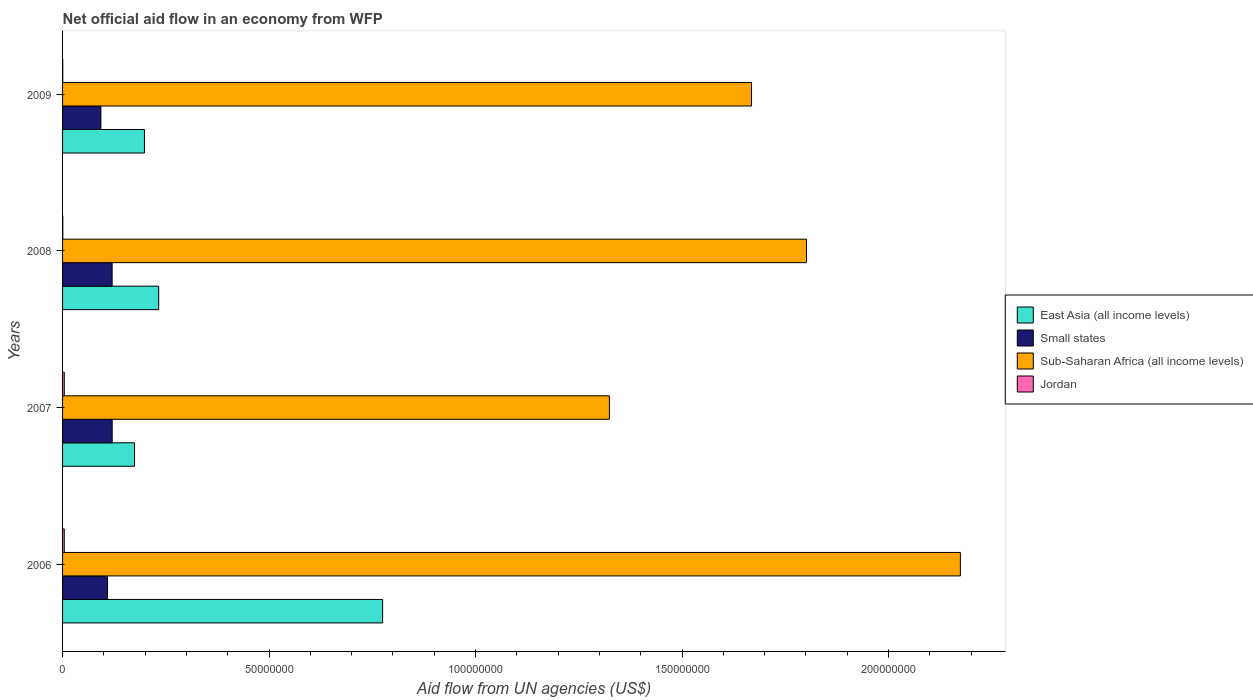How many different coloured bars are there?
Offer a very short reply. 4. How many groups of bars are there?
Offer a very short reply. 4. Are the number of bars per tick equal to the number of legend labels?
Offer a terse response. Yes. Are the number of bars on each tick of the Y-axis equal?
Give a very brief answer. Yes. How many bars are there on the 1st tick from the bottom?
Your response must be concise. 4. What is the net official aid flow in Jordan in 2009?
Offer a terse response. 5.00e+04. Across all years, what is the maximum net official aid flow in Sub-Saharan Africa (all income levels)?
Give a very brief answer. 2.17e+08. Across all years, what is the minimum net official aid flow in Sub-Saharan Africa (all income levels)?
Ensure brevity in your answer.  1.32e+08. What is the total net official aid flow in Sub-Saharan Africa (all income levels) in the graph?
Your response must be concise. 6.97e+08. What is the difference between the net official aid flow in Small states in 2006 and that in 2009?
Provide a short and direct response. 1.61e+06. What is the difference between the net official aid flow in Jordan in 2009 and the net official aid flow in East Asia (all income levels) in 2007?
Make the answer very short. -1.74e+07. What is the average net official aid flow in Jordan per year?
Keep it short and to the point. 2.35e+05. In the year 2008, what is the difference between the net official aid flow in Jordan and net official aid flow in Small states?
Your answer should be compact. -1.19e+07. What is the ratio of the net official aid flow in Small states in 2006 to that in 2008?
Give a very brief answer. 0.91. Is the net official aid flow in Sub-Saharan Africa (all income levels) in 2006 less than that in 2007?
Your answer should be compact. No. Is the difference between the net official aid flow in Jordan in 2008 and 2009 greater than the difference between the net official aid flow in Small states in 2008 and 2009?
Provide a succinct answer. No. What is the difference between the highest and the lowest net official aid flow in East Asia (all income levels)?
Your response must be concise. 6.01e+07. Is the sum of the net official aid flow in Small states in 2007 and 2009 greater than the maximum net official aid flow in East Asia (all income levels) across all years?
Your response must be concise. No. Is it the case that in every year, the sum of the net official aid flow in Sub-Saharan Africa (all income levels) and net official aid flow in Jordan is greater than the sum of net official aid flow in East Asia (all income levels) and net official aid flow in Small states?
Ensure brevity in your answer.  Yes. What does the 1st bar from the top in 2009 represents?
Provide a short and direct response. Jordan. What does the 4th bar from the bottom in 2008 represents?
Your response must be concise. Jordan. How many bars are there?
Your answer should be very brief. 16. Are all the bars in the graph horizontal?
Provide a succinct answer. Yes. What is the difference between two consecutive major ticks on the X-axis?
Ensure brevity in your answer.  5.00e+07. Does the graph contain grids?
Offer a very short reply. No. How many legend labels are there?
Offer a terse response. 4. How are the legend labels stacked?
Keep it short and to the point. Vertical. What is the title of the graph?
Your response must be concise. Net official aid flow in an economy from WFP. Does "Mali" appear as one of the legend labels in the graph?
Your answer should be very brief. No. What is the label or title of the X-axis?
Give a very brief answer. Aid flow from UN agencies (US$). What is the Aid flow from UN agencies (US$) of East Asia (all income levels) in 2006?
Keep it short and to the point. 7.75e+07. What is the Aid flow from UN agencies (US$) in Small states in 2006?
Offer a very short reply. 1.09e+07. What is the Aid flow from UN agencies (US$) in Sub-Saharan Africa (all income levels) in 2006?
Your response must be concise. 2.17e+08. What is the Aid flow from UN agencies (US$) of Jordan in 2006?
Your answer should be compact. 4.10e+05. What is the Aid flow from UN agencies (US$) of East Asia (all income levels) in 2007?
Give a very brief answer. 1.74e+07. What is the Aid flow from UN agencies (US$) of Small states in 2007?
Your answer should be compact. 1.20e+07. What is the Aid flow from UN agencies (US$) of Sub-Saharan Africa (all income levels) in 2007?
Provide a short and direct response. 1.32e+08. What is the Aid flow from UN agencies (US$) in Jordan in 2007?
Give a very brief answer. 4.20e+05. What is the Aid flow from UN agencies (US$) of East Asia (all income levels) in 2008?
Your answer should be very brief. 2.33e+07. What is the Aid flow from UN agencies (US$) of Sub-Saharan Africa (all income levels) in 2008?
Provide a succinct answer. 1.80e+08. What is the Aid flow from UN agencies (US$) in Jordan in 2008?
Your answer should be compact. 6.00e+04. What is the Aid flow from UN agencies (US$) in East Asia (all income levels) in 2009?
Provide a succinct answer. 1.98e+07. What is the Aid flow from UN agencies (US$) of Small states in 2009?
Your answer should be compact. 9.28e+06. What is the Aid flow from UN agencies (US$) in Sub-Saharan Africa (all income levels) in 2009?
Provide a succinct answer. 1.67e+08. What is the Aid flow from UN agencies (US$) in Jordan in 2009?
Offer a terse response. 5.00e+04. Across all years, what is the maximum Aid flow from UN agencies (US$) in East Asia (all income levels)?
Make the answer very short. 7.75e+07. Across all years, what is the maximum Aid flow from UN agencies (US$) in Small states?
Ensure brevity in your answer.  1.20e+07. Across all years, what is the maximum Aid flow from UN agencies (US$) in Sub-Saharan Africa (all income levels)?
Ensure brevity in your answer.  2.17e+08. Across all years, what is the minimum Aid flow from UN agencies (US$) in East Asia (all income levels)?
Ensure brevity in your answer.  1.74e+07. Across all years, what is the minimum Aid flow from UN agencies (US$) of Small states?
Your answer should be compact. 9.28e+06. Across all years, what is the minimum Aid flow from UN agencies (US$) of Sub-Saharan Africa (all income levels)?
Keep it short and to the point. 1.32e+08. Across all years, what is the minimum Aid flow from UN agencies (US$) in Jordan?
Your answer should be compact. 5.00e+04. What is the total Aid flow from UN agencies (US$) in East Asia (all income levels) in the graph?
Your answer should be compact. 1.38e+08. What is the total Aid flow from UN agencies (US$) in Small states in the graph?
Your answer should be compact. 4.42e+07. What is the total Aid flow from UN agencies (US$) of Sub-Saharan Africa (all income levels) in the graph?
Your answer should be very brief. 6.97e+08. What is the total Aid flow from UN agencies (US$) of Jordan in the graph?
Provide a short and direct response. 9.40e+05. What is the difference between the Aid flow from UN agencies (US$) of East Asia (all income levels) in 2006 and that in 2007?
Make the answer very short. 6.01e+07. What is the difference between the Aid flow from UN agencies (US$) of Small states in 2006 and that in 2007?
Offer a terse response. -1.12e+06. What is the difference between the Aid flow from UN agencies (US$) of Sub-Saharan Africa (all income levels) in 2006 and that in 2007?
Make the answer very short. 8.50e+07. What is the difference between the Aid flow from UN agencies (US$) of East Asia (all income levels) in 2006 and that in 2008?
Your response must be concise. 5.42e+07. What is the difference between the Aid flow from UN agencies (US$) of Small states in 2006 and that in 2008?
Offer a very short reply. -1.11e+06. What is the difference between the Aid flow from UN agencies (US$) of Sub-Saharan Africa (all income levels) in 2006 and that in 2008?
Give a very brief answer. 3.73e+07. What is the difference between the Aid flow from UN agencies (US$) in East Asia (all income levels) in 2006 and that in 2009?
Your answer should be very brief. 5.77e+07. What is the difference between the Aid flow from UN agencies (US$) in Small states in 2006 and that in 2009?
Provide a short and direct response. 1.61e+06. What is the difference between the Aid flow from UN agencies (US$) of Sub-Saharan Africa (all income levels) in 2006 and that in 2009?
Provide a short and direct response. 5.06e+07. What is the difference between the Aid flow from UN agencies (US$) of East Asia (all income levels) in 2007 and that in 2008?
Give a very brief answer. -5.85e+06. What is the difference between the Aid flow from UN agencies (US$) of Small states in 2007 and that in 2008?
Make the answer very short. 10000. What is the difference between the Aid flow from UN agencies (US$) of Sub-Saharan Africa (all income levels) in 2007 and that in 2008?
Your answer should be very brief. -4.77e+07. What is the difference between the Aid flow from UN agencies (US$) of East Asia (all income levels) in 2007 and that in 2009?
Your answer should be very brief. -2.40e+06. What is the difference between the Aid flow from UN agencies (US$) of Small states in 2007 and that in 2009?
Give a very brief answer. 2.73e+06. What is the difference between the Aid flow from UN agencies (US$) of Sub-Saharan Africa (all income levels) in 2007 and that in 2009?
Make the answer very short. -3.44e+07. What is the difference between the Aid flow from UN agencies (US$) in East Asia (all income levels) in 2008 and that in 2009?
Keep it short and to the point. 3.45e+06. What is the difference between the Aid flow from UN agencies (US$) in Small states in 2008 and that in 2009?
Provide a short and direct response. 2.72e+06. What is the difference between the Aid flow from UN agencies (US$) in Sub-Saharan Africa (all income levels) in 2008 and that in 2009?
Your response must be concise. 1.33e+07. What is the difference between the Aid flow from UN agencies (US$) of East Asia (all income levels) in 2006 and the Aid flow from UN agencies (US$) of Small states in 2007?
Your response must be concise. 6.55e+07. What is the difference between the Aid flow from UN agencies (US$) of East Asia (all income levels) in 2006 and the Aid flow from UN agencies (US$) of Sub-Saharan Africa (all income levels) in 2007?
Give a very brief answer. -5.49e+07. What is the difference between the Aid flow from UN agencies (US$) of East Asia (all income levels) in 2006 and the Aid flow from UN agencies (US$) of Jordan in 2007?
Provide a short and direct response. 7.71e+07. What is the difference between the Aid flow from UN agencies (US$) of Small states in 2006 and the Aid flow from UN agencies (US$) of Sub-Saharan Africa (all income levels) in 2007?
Provide a short and direct response. -1.22e+08. What is the difference between the Aid flow from UN agencies (US$) of Small states in 2006 and the Aid flow from UN agencies (US$) of Jordan in 2007?
Make the answer very short. 1.05e+07. What is the difference between the Aid flow from UN agencies (US$) in Sub-Saharan Africa (all income levels) in 2006 and the Aid flow from UN agencies (US$) in Jordan in 2007?
Ensure brevity in your answer.  2.17e+08. What is the difference between the Aid flow from UN agencies (US$) of East Asia (all income levels) in 2006 and the Aid flow from UN agencies (US$) of Small states in 2008?
Your response must be concise. 6.55e+07. What is the difference between the Aid flow from UN agencies (US$) of East Asia (all income levels) in 2006 and the Aid flow from UN agencies (US$) of Sub-Saharan Africa (all income levels) in 2008?
Your answer should be compact. -1.03e+08. What is the difference between the Aid flow from UN agencies (US$) in East Asia (all income levels) in 2006 and the Aid flow from UN agencies (US$) in Jordan in 2008?
Make the answer very short. 7.74e+07. What is the difference between the Aid flow from UN agencies (US$) of Small states in 2006 and the Aid flow from UN agencies (US$) of Sub-Saharan Africa (all income levels) in 2008?
Offer a very short reply. -1.69e+08. What is the difference between the Aid flow from UN agencies (US$) of Small states in 2006 and the Aid flow from UN agencies (US$) of Jordan in 2008?
Ensure brevity in your answer.  1.08e+07. What is the difference between the Aid flow from UN agencies (US$) of Sub-Saharan Africa (all income levels) in 2006 and the Aid flow from UN agencies (US$) of Jordan in 2008?
Your answer should be compact. 2.17e+08. What is the difference between the Aid flow from UN agencies (US$) of East Asia (all income levels) in 2006 and the Aid flow from UN agencies (US$) of Small states in 2009?
Give a very brief answer. 6.82e+07. What is the difference between the Aid flow from UN agencies (US$) in East Asia (all income levels) in 2006 and the Aid flow from UN agencies (US$) in Sub-Saharan Africa (all income levels) in 2009?
Provide a short and direct response. -8.93e+07. What is the difference between the Aid flow from UN agencies (US$) in East Asia (all income levels) in 2006 and the Aid flow from UN agencies (US$) in Jordan in 2009?
Provide a succinct answer. 7.74e+07. What is the difference between the Aid flow from UN agencies (US$) in Small states in 2006 and the Aid flow from UN agencies (US$) in Sub-Saharan Africa (all income levels) in 2009?
Make the answer very short. -1.56e+08. What is the difference between the Aid flow from UN agencies (US$) in Small states in 2006 and the Aid flow from UN agencies (US$) in Jordan in 2009?
Provide a short and direct response. 1.08e+07. What is the difference between the Aid flow from UN agencies (US$) of Sub-Saharan Africa (all income levels) in 2006 and the Aid flow from UN agencies (US$) of Jordan in 2009?
Your answer should be very brief. 2.17e+08. What is the difference between the Aid flow from UN agencies (US$) in East Asia (all income levels) in 2007 and the Aid flow from UN agencies (US$) in Small states in 2008?
Your answer should be very brief. 5.43e+06. What is the difference between the Aid flow from UN agencies (US$) in East Asia (all income levels) in 2007 and the Aid flow from UN agencies (US$) in Sub-Saharan Africa (all income levels) in 2008?
Your answer should be compact. -1.63e+08. What is the difference between the Aid flow from UN agencies (US$) of East Asia (all income levels) in 2007 and the Aid flow from UN agencies (US$) of Jordan in 2008?
Your answer should be compact. 1.74e+07. What is the difference between the Aid flow from UN agencies (US$) of Small states in 2007 and the Aid flow from UN agencies (US$) of Sub-Saharan Africa (all income levels) in 2008?
Make the answer very short. -1.68e+08. What is the difference between the Aid flow from UN agencies (US$) of Small states in 2007 and the Aid flow from UN agencies (US$) of Jordan in 2008?
Your response must be concise. 1.20e+07. What is the difference between the Aid flow from UN agencies (US$) of Sub-Saharan Africa (all income levels) in 2007 and the Aid flow from UN agencies (US$) of Jordan in 2008?
Offer a very short reply. 1.32e+08. What is the difference between the Aid flow from UN agencies (US$) of East Asia (all income levels) in 2007 and the Aid flow from UN agencies (US$) of Small states in 2009?
Ensure brevity in your answer.  8.15e+06. What is the difference between the Aid flow from UN agencies (US$) of East Asia (all income levels) in 2007 and the Aid flow from UN agencies (US$) of Sub-Saharan Africa (all income levels) in 2009?
Provide a succinct answer. -1.49e+08. What is the difference between the Aid flow from UN agencies (US$) of East Asia (all income levels) in 2007 and the Aid flow from UN agencies (US$) of Jordan in 2009?
Make the answer very short. 1.74e+07. What is the difference between the Aid flow from UN agencies (US$) in Small states in 2007 and the Aid flow from UN agencies (US$) in Sub-Saharan Africa (all income levels) in 2009?
Your answer should be compact. -1.55e+08. What is the difference between the Aid flow from UN agencies (US$) in Small states in 2007 and the Aid flow from UN agencies (US$) in Jordan in 2009?
Your answer should be compact. 1.20e+07. What is the difference between the Aid flow from UN agencies (US$) in Sub-Saharan Africa (all income levels) in 2007 and the Aid flow from UN agencies (US$) in Jordan in 2009?
Your answer should be compact. 1.32e+08. What is the difference between the Aid flow from UN agencies (US$) in East Asia (all income levels) in 2008 and the Aid flow from UN agencies (US$) in Small states in 2009?
Provide a short and direct response. 1.40e+07. What is the difference between the Aid flow from UN agencies (US$) of East Asia (all income levels) in 2008 and the Aid flow from UN agencies (US$) of Sub-Saharan Africa (all income levels) in 2009?
Provide a succinct answer. -1.44e+08. What is the difference between the Aid flow from UN agencies (US$) of East Asia (all income levels) in 2008 and the Aid flow from UN agencies (US$) of Jordan in 2009?
Give a very brief answer. 2.32e+07. What is the difference between the Aid flow from UN agencies (US$) in Small states in 2008 and the Aid flow from UN agencies (US$) in Sub-Saharan Africa (all income levels) in 2009?
Provide a short and direct response. -1.55e+08. What is the difference between the Aid flow from UN agencies (US$) in Small states in 2008 and the Aid flow from UN agencies (US$) in Jordan in 2009?
Provide a short and direct response. 1.20e+07. What is the difference between the Aid flow from UN agencies (US$) of Sub-Saharan Africa (all income levels) in 2008 and the Aid flow from UN agencies (US$) of Jordan in 2009?
Offer a very short reply. 1.80e+08. What is the average Aid flow from UN agencies (US$) in East Asia (all income levels) per year?
Ensure brevity in your answer.  3.45e+07. What is the average Aid flow from UN agencies (US$) of Small states per year?
Keep it short and to the point. 1.10e+07. What is the average Aid flow from UN agencies (US$) in Sub-Saharan Africa (all income levels) per year?
Provide a short and direct response. 1.74e+08. What is the average Aid flow from UN agencies (US$) in Jordan per year?
Your response must be concise. 2.35e+05. In the year 2006, what is the difference between the Aid flow from UN agencies (US$) of East Asia (all income levels) and Aid flow from UN agencies (US$) of Small states?
Your answer should be compact. 6.66e+07. In the year 2006, what is the difference between the Aid flow from UN agencies (US$) in East Asia (all income levels) and Aid flow from UN agencies (US$) in Sub-Saharan Africa (all income levels)?
Give a very brief answer. -1.40e+08. In the year 2006, what is the difference between the Aid flow from UN agencies (US$) in East Asia (all income levels) and Aid flow from UN agencies (US$) in Jordan?
Your answer should be compact. 7.71e+07. In the year 2006, what is the difference between the Aid flow from UN agencies (US$) in Small states and Aid flow from UN agencies (US$) in Sub-Saharan Africa (all income levels)?
Ensure brevity in your answer.  -2.07e+08. In the year 2006, what is the difference between the Aid flow from UN agencies (US$) of Small states and Aid flow from UN agencies (US$) of Jordan?
Offer a terse response. 1.05e+07. In the year 2006, what is the difference between the Aid flow from UN agencies (US$) in Sub-Saharan Africa (all income levels) and Aid flow from UN agencies (US$) in Jordan?
Provide a succinct answer. 2.17e+08. In the year 2007, what is the difference between the Aid flow from UN agencies (US$) in East Asia (all income levels) and Aid flow from UN agencies (US$) in Small states?
Offer a terse response. 5.42e+06. In the year 2007, what is the difference between the Aid flow from UN agencies (US$) in East Asia (all income levels) and Aid flow from UN agencies (US$) in Sub-Saharan Africa (all income levels)?
Your response must be concise. -1.15e+08. In the year 2007, what is the difference between the Aid flow from UN agencies (US$) in East Asia (all income levels) and Aid flow from UN agencies (US$) in Jordan?
Make the answer very short. 1.70e+07. In the year 2007, what is the difference between the Aid flow from UN agencies (US$) in Small states and Aid flow from UN agencies (US$) in Sub-Saharan Africa (all income levels)?
Your answer should be very brief. -1.20e+08. In the year 2007, what is the difference between the Aid flow from UN agencies (US$) of Small states and Aid flow from UN agencies (US$) of Jordan?
Give a very brief answer. 1.16e+07. In the year 2007, what is the difference between the Aid flow from UN agencies (US$) of Sub-Saharan Africa (all income levels) and Aid flow from UN agencies (US$) of Jordan?
Provide a short and direct response. 1.32e+08. In the year 2008, what is the difference between the Aid flow from UN agencies (US$) of East Asia (all income levels) and Aid flow from UN agencies (US$) of Small states?
Offer a terse response. 1.13e+07. In the year 2008, what is the difference between the Aid flow from UN agencies (US$) in East Asia (all income levels) and Aid flow from UN agencies (US$) in Sub-Saharan Africa (all income levels)?
Offer a very short reply. -1.57e+08. In the year 2008, what is the difference between the Aid flow from UN agencies (US$) of East Asia (all income levels) and Aid flow from UN agencies (US$) of Jordan?
Provide a succinct answer. 2.32e+07. In the year 2008, what is the difference between the Aid flow from UN agencies (US$) in Small states and Aid flow from UN agencies (US$) in Sub-Saharan Africa (all income levels)?
Give a very brief answer. -1.68e+08. In the year 2008, what is the difference between the Aid flow from UN agencies (US$) of Small states and Aid flow from UN agencies (US$) of Jordan?
Offer a very short reply. 1.19e+07. In the year 2008, what is the difference between the Aid flow from UN agencies (US$) in Sub-Saharan Africa (all income levels) and Aid flow from UN agencies (US$) in Jordan?
Ensure brevity in your answer.  1.80e+08. In the year 2009, what is the difference between the Aid flow from UN agencies (US$) of East Asia (all income levels) and Aid flow from UN agencies (US$) of Small states?
Your answer should be very brief. 1.06e+07. In the year 2009, what is the difference between the Aid flow from UN agencies (US$) of East Asia (all income levels) and Aid flow from UN agencies (US$) of Sub-Saharan Africa (all income levels)?
Your answer should be very brief. -1.47e+08. In the year 2009, what is the difference between the Aid flow from UN agencies (US$) of East Asia (all income levels) and Aid flow from UN agencies (US$) of Jordan?
Your answer should be compact. 1.98e+07. In the year 2009, what is the difference between the Aid flow from UN agencies (US$) in Small states and Aid flow from UN agencies (US$) in Sub-Saharan Africa (all income levels)?
Keep it short and to the point. -1.58e+08. In the year 2009, what is the difference between the Aid flow from UN agencies (US$) of Small states and Aid flow from UN agencies (US$) of Jordan?
Make the answer very short. 9.23e+06. In the year 2009, what is the difference between the Aid flow from UN agencies (US$) in Sub-Saharan Africa (all income levels) and Aid flow from UN agencies (US$) in Jordan?
Provide a succinct answer. 1.67e+08. What is the ratio of the Aid flow from UN agencies (US$) in East Asia (all income levels) in 2006 to that in 2007?
Provide a short and direct response. 4.45. What is the ratio of the Aid flow from UN agencies (US$) in Small states in 2006 to that in 2007?
Your answer should be compact. 0.91. What is the ratio of the Aid flow from UN agencies (US$) in Sub-Saharan Africa (all income levels) in 2006 to that in 2007?
Make the answer very short. 1.64. What is the ratio of the Aid flow from UN agencies (US$) in Jordan in 2006 to that in 2007?
Keep it short and to the point. 0.98. What is the ratio of the Aid flow from UN agencies (US$) in East Asia (all income levels) in 2006 to that in 2008?
Your answer should be very brief. 3.33. What is the ratio of the Aid flow from UN agencies (US$) in Small states in 2006 to that in 2008?
Your answer should be very brief. 0.91. What is the ratio of the Aid flow from UN agencies (US$) of Sub-Saharan Africa (all income levels) in 2006 to that in 2008?
Keep it short and to the point. 1.21. What is the ratio of the Aid flow from UN agencies (US$) in Jordan in 2006 to that in 2008?
Provide a short and direct response. 6.83. What is the ratio of the Aid flow from UN agencies (US$) in East Asia (all income levels) in 2006 to that in 2009?
Keep it short and to the point. 3.91. What is the ratio of the Aid flow from UN agencies (US$) in Small states in 2006 to that in 2009?
Make the answer very short. 1.17. What is the ratio of the Aid flow from UN agencies (US$) in Sub-Saharan Africa (all income levels) in 2006 to that in 2009?
Keep it short and to the point. 1.3. What is the ratio of the Aid flow from UN agencies (US$) of Jordan in 2006 to that in 2009?
Your answer should be compact. 8.2. What is the ratio of the Aid flow from UN agencies (US$) in East Asia (all income levels) in 2007 to that in 2008?
Your answer should be very brief. 0.75. What is the ratio of the Aid flow from UN agencies (US$) in Sub-Saharan Africa (all income levels) in 2007 to that in 2008?
Your response must be concise. 0.74. What is the ratio of the Aid flow from UN agencies (US$) of East Asia (all income levels) in 2007 to that in 2009?
Give a very brief answer. 0.88. What is the ratio of the Aid flow from UN agencies (US$) in Small states in 2007 to that in 2009?
Give a very brief answer. 1.29. What is the ratio of the Aid flow from UN agencies (US$) in Sub-Saharan Africa (all income levels) in 2007 to that in 2009?
Ensure brevity in your answer.  0.79. What is the ratio of the Aid flow from UN agencies (US$) of Jordan in 2007 to that in 2009?
Ensure brevity in your answer.  8.4. What is the ratio of the Aid flow from UN agencies (US$) in East Asia (all income levels) in 2008 to that in 2009?
Ensure brevity in your answer.  1.17. What is the ratio of the Aid flow from UN agencies (US$) of Small states in 2008 to that in 2009?
Offer a very short reply. 1.29. What is the ratio of the Aid flow from UN agencies (US$) in Sub-Saharan Africa (all income levels) in 2008 to that in 2009?
Make the answer very short. 1.08. What is the ratio of the Aid flow from UN agencies (US$) in Jordan in 2008 to that in 2009?
Your answer should be very brief. 1.2. What is the difference between the highest and the second highest Aid flow from UN agencies (US$) in East Asia (all income levels)?
Offer a terse response. 5.42e+07. What is the difference between the highest and the second highest Aid flow from UN agencies (US$) in Small states?
Your response must be concise. 10000. What is the difference between the highest and the second highest Aid flow from UN agencies (US$) in Sub-Saharan Africa (all income levels)?
Make the answer very short. 3.73e+07. What is the difference between the highest and the lowest Aid flow from UN agencies (US$) of East Asia (all income levels)?
Provide a short and direct response. 6.01e+07. What is the difference between the highest and the lowest Aid flow from UN agencies (US$) of Small states?
Provide a short and direct response. 2.73e+06. What is the difference between the highest and the lowest Aid flow from UN agencies (US$) of Sub-Saharan Africa (all income levels)?
Ensure brevity in your answer.  8.50e+07. What is the difference between the highest and the lowest Aid flow from UN agencies (US$) in Jordan?
Ensure brevity in your answer.  3.70e+05. 